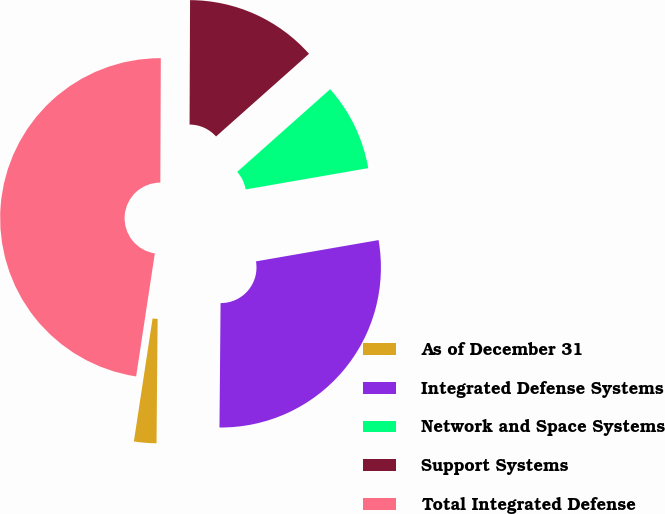Convert chart. <chart><loc_0><loc_0><loc_500><loc_500><pie_chart><fcel>As of December 31<fcel>Integrated Defense Systems<fcel>Network and Space Systems<fcel>Support Systems<fcel>Total Integrated Defense<nl><fcel>2.26%<fcel>27.88%<fcel>8.83%<fcel>13.37%<fcel>47.66%<nl></chart> 